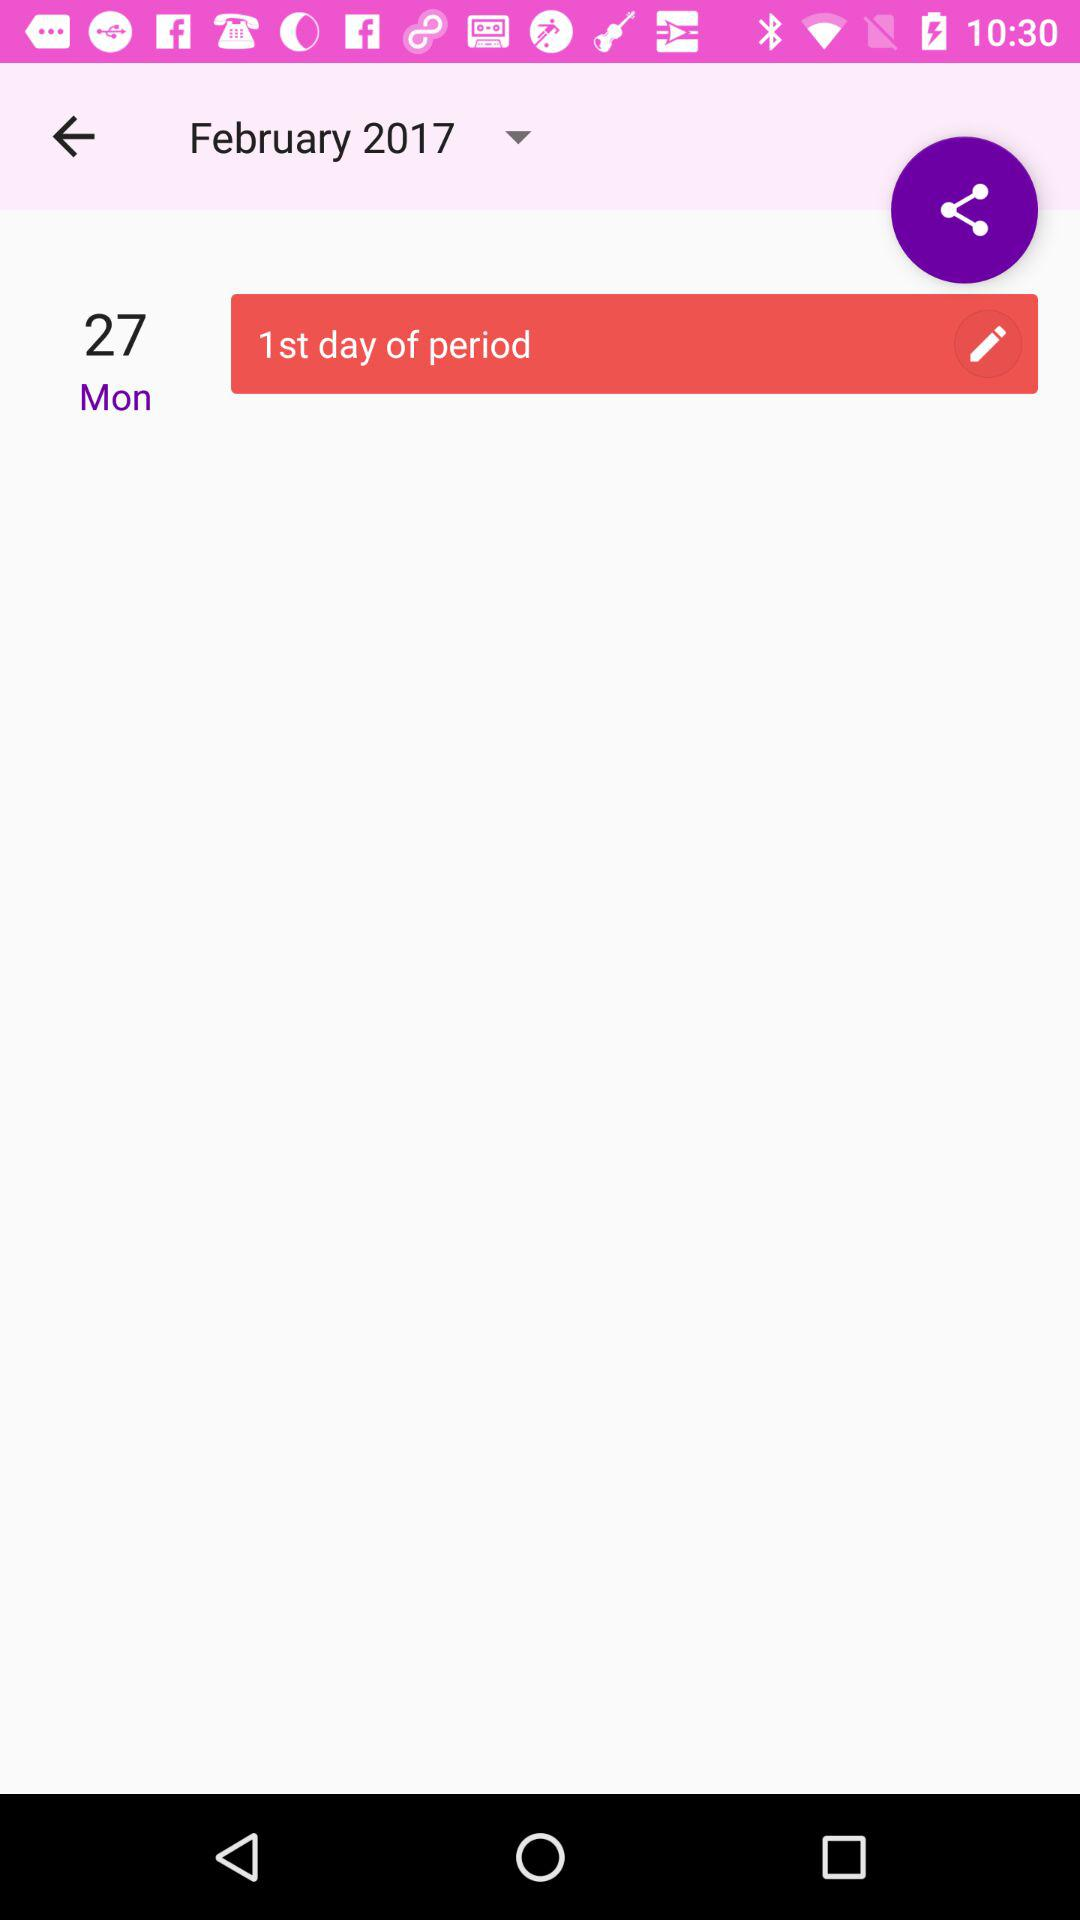What is the first day of the period? The first day of the period is Monday. 